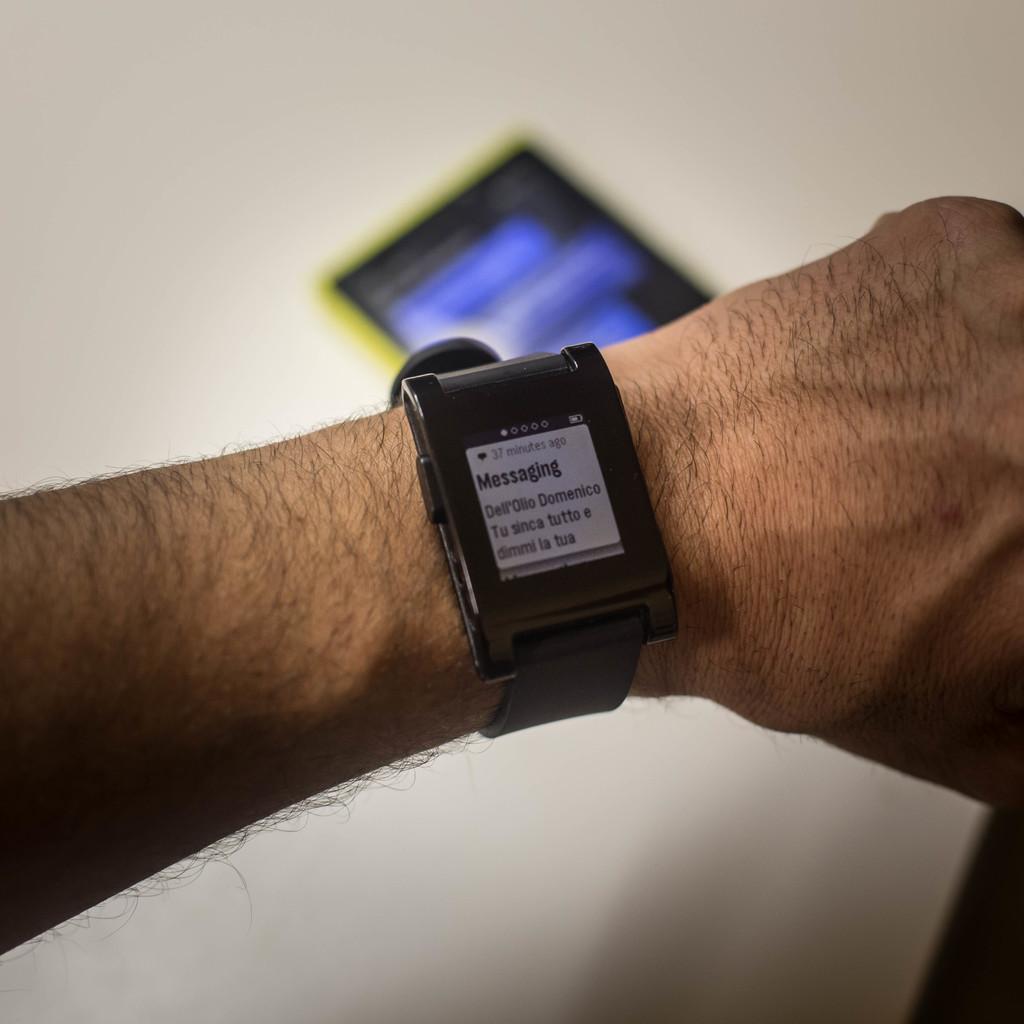How many minutes are displayed on the watch?
Offer a terse response. 37. What is the name of the open app on the watch?
Offer a terse response. Messaging. 